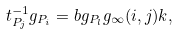<formula> <loc_0><loc_0><loc_500><loc_500>t _ { P _ { j } } ^ { - 1 } g _ { P _ { i } } = b g _ { P _ { l } } g _ { \infty } ( i , j ) k ,</formula> 